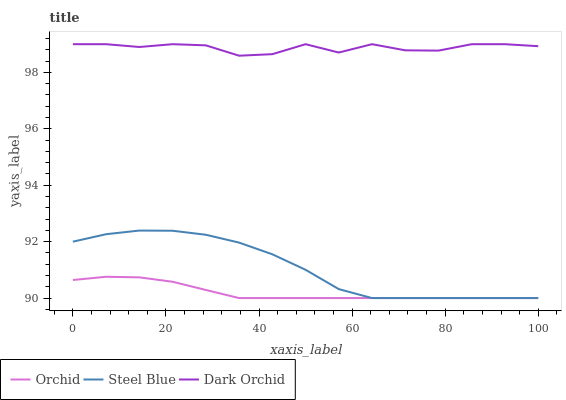Does Dark Orchid have the minimum area under the curve?
Answer yes or no. No. Does Orchid have the maximum area under the curve?
Answer yes or no. No. Is Dark Orchid the smoothest?
Answer yes or no. No. Is Orchid the roughest?
Answer yes or no. No. Does Dark Orchid have the lowest value?
Answer yes or no. No. Does Orchid have the highest value?
Answer yes or no. No. Is Orchid less than Dark Orchid?
Answer yes or no. Yes. Is Dark Orchid greater than Steel Blue?
Answer yes or no. Yes. Does Orchid intersect Dark Orchid?
Answer yes or no. No. 